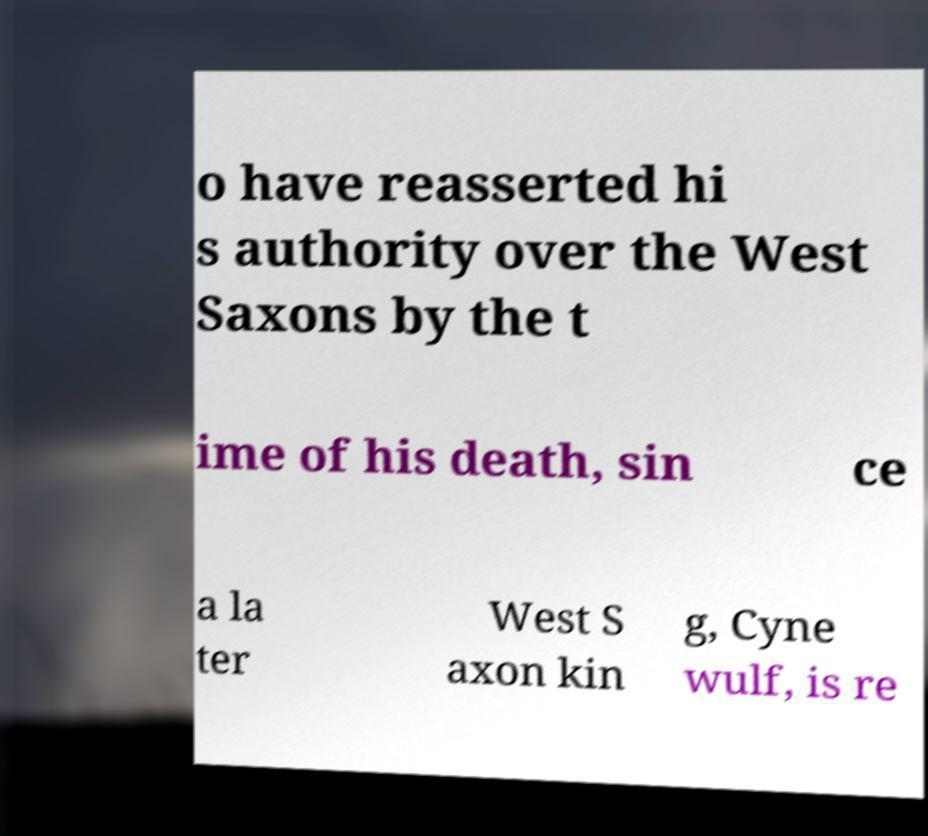There's text embedded in this image that I need extracted. Can you transcribe it verbatim? o have reasserted hi s authority over the West Saxons by the t ime of his death, sin ce a la ter West S axon kin g, Cyne wulf, is re 